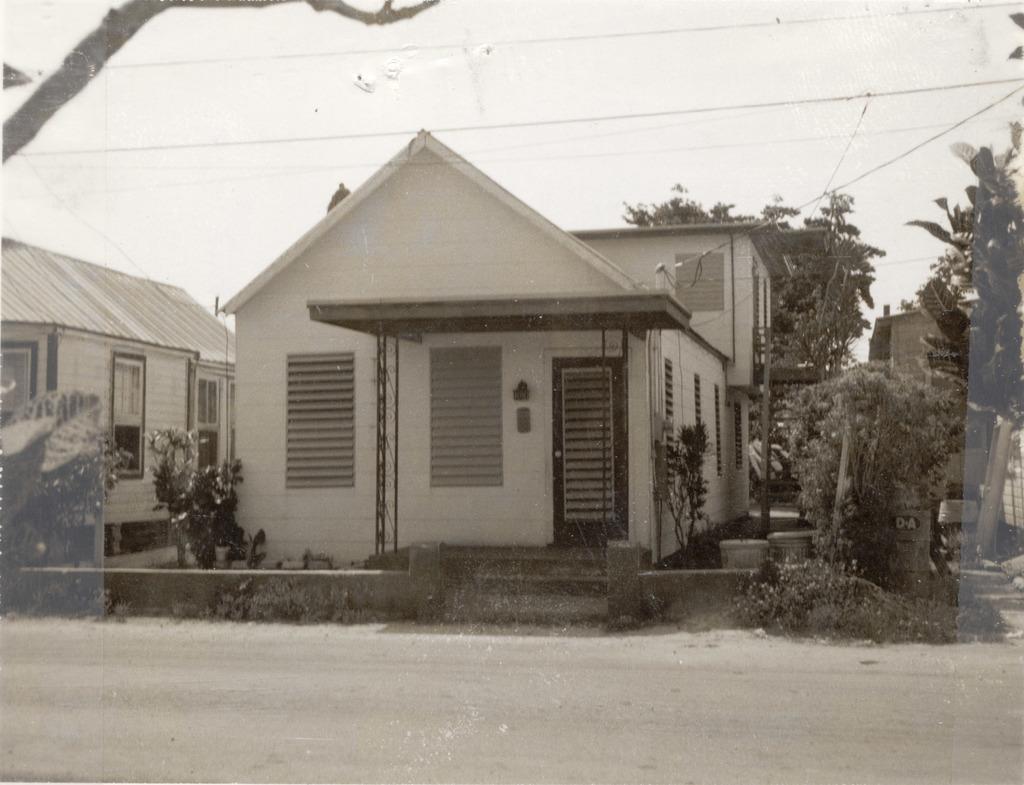In one or two sentences, can you explain what this image depicts? The picture is a black and white image. In the foreground of the picture there is road. In the center of the picture there are plants, trees, houses, windows and doors. At the top there are cables and a trunk of the tree. It is a sunny day. 